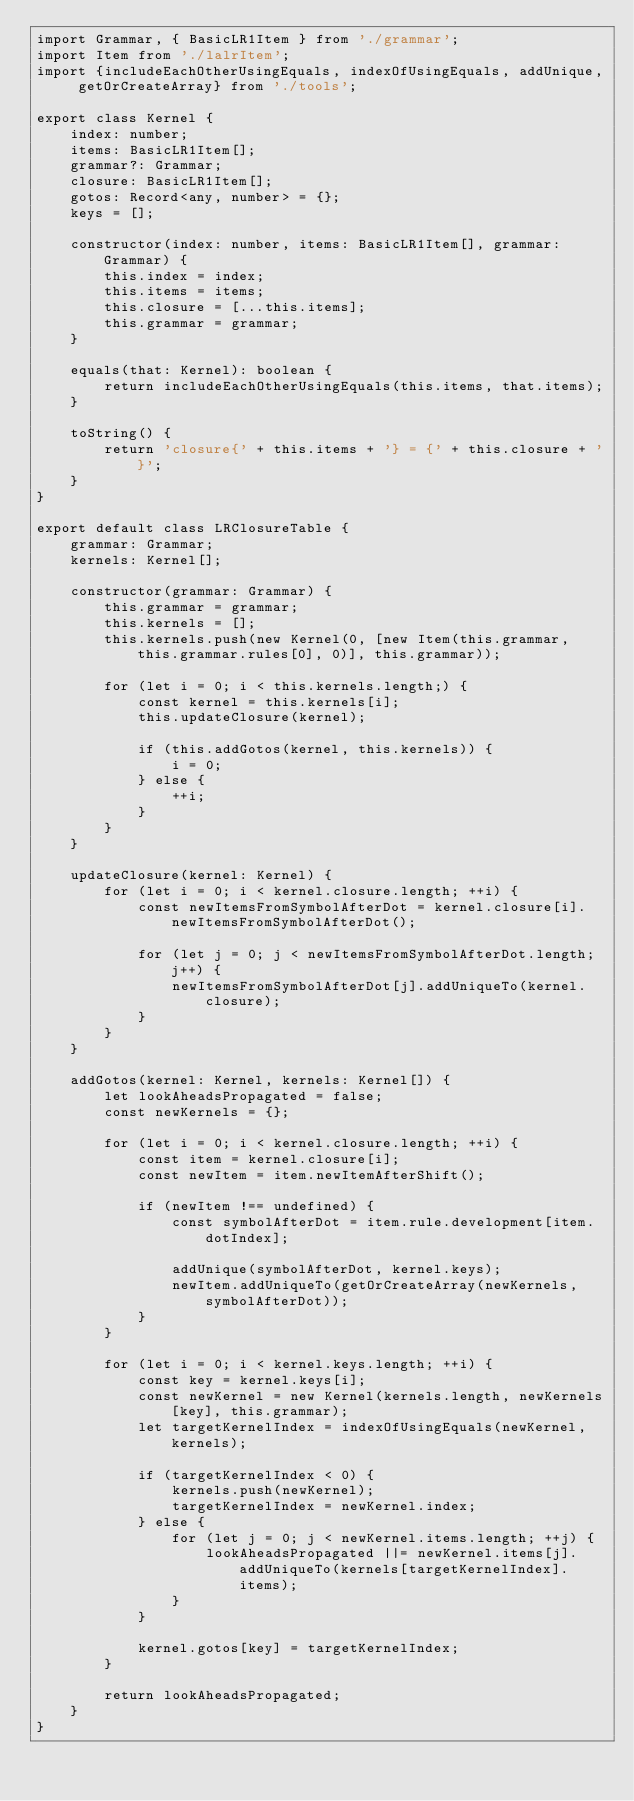Convert code to text. <code><loc_0><loc_0><loc_500><loc_500><_TypeScript_>import Grammar, { BasicLR1Item } from './grammar';
import Item from './lalrItem';
import {includeEachOtherUsingEquals, indexOfUsingEquals, addUnique, getOrCreateArray} from './tools';

export class Kernel {
	index: number;
	items: BasicLR1Item[];
	grammar?: Grammar;
	closure: BasicLR1Item[];
	gotos: Record<any, number> = {};
	keys = [];

	constructor(index: number, items: BasicLR1Item[], grammar: Grammar) {
	    this.index = index;
	    this.items = items;
	    this.closure = [...this.items];
	    this.grammar = grammar;
	}

	equals(that: Kernel): boolean {
	    return includeEachOtherUsingEquals(this.items, that.items);
	}

	toString() {
	    return 'closure{' + this.items + '} = {' + this.closure + '}';
	}
}

export default class LRClosureTable {
    grammar: Grammar;
    kernels: Kernel[];

    constructor(grammar: Grammar) {
        this.grammar = grammar;
        this.kernels = [];
        this.kernels.push(new Kernel(0, [new Item(this.grammar, this.grammar.rules[0], 0)], this.grammar));

        for (let i = 0; i < this.kernels.length;) {
            const kernel = this.kernels[i];
            this.updateClosure(kernel);

            if (this.addGotos(kernel, this.kernels)) {
                i = 0;
            } else {
                ++i;
            }
        }
    }

    updateClosure(kernel: Kernel) {
        for (let i = 0; i < kernel.closure.length; ++i) {
            const newItemsFromSymbolAfterDot = kernel.closure[i].newItemsFromSymbolAfterDot();

            for (let j = 0; j < newItemsFromSymbolAfterDot.length; j++) {
                newItemsFromSymbolAfterDot[j].addUniqueTo(kernel.closure);
            }
        }
    }

    addGotos(kernel: Kernel, kernels: Kernel[]) {
        let lookAheadsPropagated = false;
        const newKernels = {};

        for (let i = 0; i < kernel.closure.length; ++i) {
            const item = kernel.closure[i];
            const newItem = item.newItemAfterShift();

            if (newItem !== undefined) {
                const symbolAfterDot = item.rule.development[item.dotIndex];

                addUnique(symbolAfterDot, kernel.keys);
                newItem.addUniqueTo(getOrCreateArray(newKernels, symbolAfterDot));
            }
        }

        for (let i = 0; i < kernel.keys.length; ++i) {
            const key = kernel.keys[i];
            const newKernel = new Kernel(kernels.length, newKernels[key], this.grammar);
            let targetKernelIndex = indexOfUsingEquals(newKernel, kernels);

            if (targetKernelIndex < 0) {
                kernels.push(newKernel);
                targetKernelIndex = newKernel.index;
            } else {
                for (let j = 0; j < newKernel.items.length; ++j) {
                    lookAheadsPropagated ||= newKernel.items[j].addUniqueTo(kernels[targetKernelIndex].items);
                }
            }

            kernel.gotos[key] = targetKernelIndex;
        }

        return lookAheadsPropagated;
    }
}

</code> 